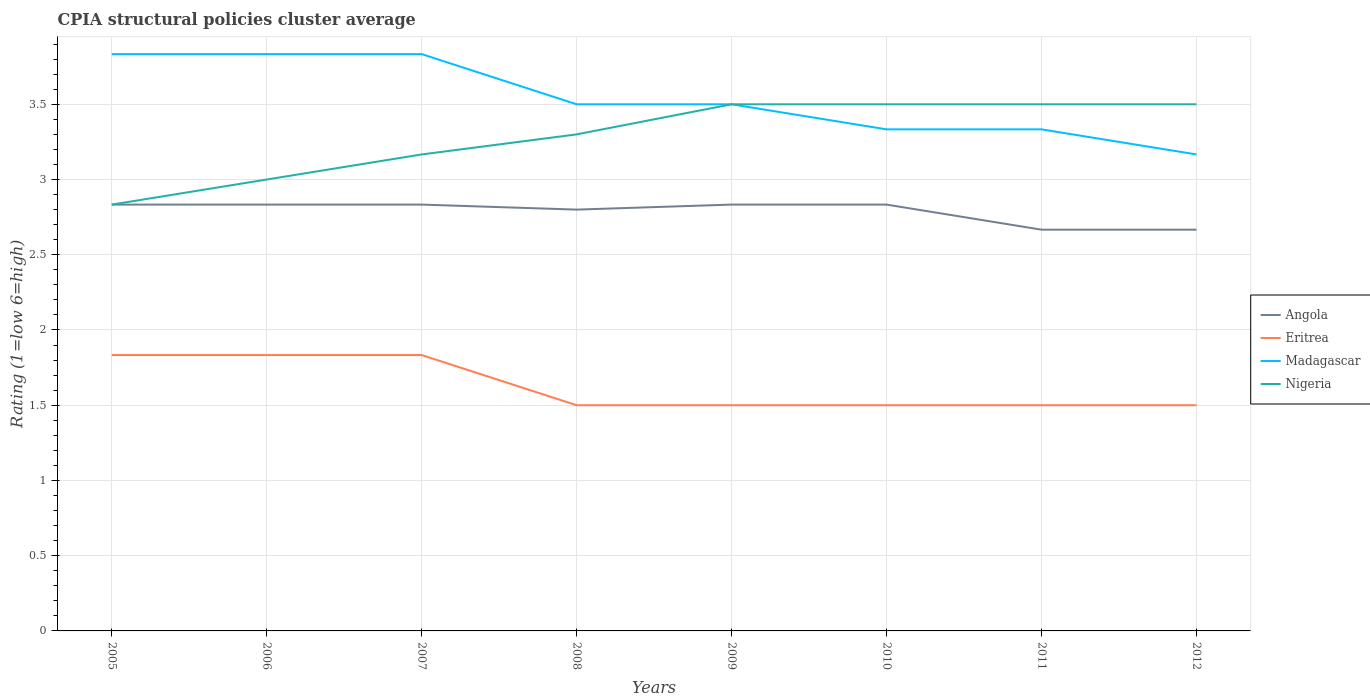How many different coloured lines are there?
Offer a very short reply. 4. Does the line corresponding to Angola intersect with the line corresponding to Madagascar?
Ensure brevity in your answer.  No. What is the total CPIA rating in Madagascar in the graph?
Keep it short and to the point. 0.17. What is the difference between the highest and the second highest CPIA rating in Nigeria?
Your answer should be very brief. 0.67. What is the difference between the highest and the lowest CPIA rating in Nigeria?
Give a very brief answer. 5. How many lines are there?
Offer a very short reply. 4. What is the difference between two consecutive major ticks on the Y-axis?
Make the answer very short. 0.5. Are the values on the major ticks of Y-axis written in scientific E-notation?
Provide a short and direct response. No. Does the graph contain grids?
Your response must be concise. Yes. Where does the legend appear in the graph?
Provide a short and direct response. Center right. How many legend labels are there?
Offer a very short reply. 4. What is the title of the graph?
Give a very brief answer. CPIA structural policies cluster average. What is the label or title of the X-axis?
Your answer should be very brief. Years. What is the Rating (1=low 6=high) in Angola in 2005?
Offer a very short reply. 2.83. What is the Rating (1=low 6=high) in Eritrea in 2005?
Keep it short and to the point. 1.83. What is the Rating (1=low 6=high) in Madagascar in 2005?
Offer a terse response. 3.83. What is the Rating (1=low 6=high) in Nigeria in 2005?
Your answer should be compact. 2.83. What is the Rating (1=low 6=high) of Angola in 2006?
Provide a short and direct response. 2.83. What is the Rating (1=low 6=high) in Eritrea in 2006?
Provide a succinct answer. 1.83. What is the Rating (1=low 6=high) in Madagascar in 2006?
Keep it short and to the point. 3.83. What is the Rating (1=low 6=high) in Angola in 2007?
Make the answer very short. 2.83. What is the Rating (1=low 6=high) of Eritrea in 2007?
Your response must be concise. 1.83. What is the Rating (1=low 6=high) in Madagascar in 2007?
Your answer should be compact. 3.83. What is the Rating (1=low 6=high) of Nigeria in 2007?
Provide a succinct answer. 3.17. What is the Rating (1=low 6=high) in Nigeria in 2008?
Give a very brief answer. 3.3. What is the Rating (1=low 6=high) of Angola in 2009?
Give a very brief answer. 2.83. What is the Rating (1=low 6=high) in Eritrea in 2009?
Keep it short and to the point. 1.5. What is the Rating (1=low 6=high) of Madagascar in 2009?
Provide a succinct answer. 3.5. What is the Rating (1=low 6=high) of Nigeria in 2009?
Provide a succinct answer. 3.5. What is the Rating (1=low 6=high) of Angola in 2010?
Your answer should be compact. 2.83. What is the Rating (1=low 6=high) of Madagascar in 2010?
Provide a succinct answer. 3.33. What is the Rating (1=low 6=high) of Nigeria in 2010?
Your answer should be compact. 3.5. What is the Rating (1=low 6=high) of Angola in 2011?
Give a very brief answer. 2.67. What is the Rating (1=low 6=high) of Madagascar in 2011?
Give a very brief answer. 3.33. What is the Rating (1=low 6=high) in Nigeria in 2011?
Your response must be concise. 3.5. What is the Rating (1=low 6=high) in Angola in 2012?
Your answer should be compact. 2.67. What is the Rating (1=low 6=high) of Madagascar in 2012?
Make the answer very short. 3.17. Across all years, what is the maximum Rating (1=low 6=high) of Angola?
Provide a short and direct response. 2.83. Across all years, what is the maximum Rating (1=low 6=high) in Eritrea?
Offer a very short reply. 1.83. Across all years, what is the maximum Rating (1=low 6=high) of Madagascar?
Offer a terse response. 3.83. Across all years, what is the maximum Rating (1=low 6=high) of Nigeria?
Offer a very short reply. 3.5. Across all years, what is the minimum Rating (1=low 6=high) in Angola?
Keep it short and to the point. 2.67. Across all years, what is the minimum Rating (1=low 6=high) in Eritrea?
Offer a terse response. 1.5. Across all years, what is the minimum Rating (1=low 6=high) of Madagascar?
Make the answer very short. 3.17. Across all years, what is the minimum Rating (1=low 6=high) of Nigeria?
Offer a very short reply. 2.83. What is the total Rating (1=low 6=high) of Angola in the graph?
Your answer should be compact. 22.3. What is the total Rating (1=low 6=high) of Eritrea in the graph?
Provide a succinct answer. 13. What is the total Rating (1=low 6=high) in Madagascar in the graph?
Offer a very short reply. 28.33. What is the total Rating (1=low 6=high) of Nigeria in the graph?
Provide a succinct answer. 26.3. What is the difference between the Rating (1=low 6=high) in Eritrea in 2005 and that in 2006?
Offer a terse response. 0. What is the difference between the Rating (1=low 6=high) in Madagascar in 2005 and that in 2006?
Offer a very short reply. 0. What is the difference between the Rating (1=low 6=high) of Nigeria in 2005 and that in 2006?
Your answer should be compact. -0.17. What is the difference between the Rating (1=low 6=high) in Angola in 2005 and that in 2007?
Keep it short and to the point. 0. What is the difference between the Rating (1=low 6=high) of Eritrea in 2005 and that in 2007?
Offer a very short reply. 0. What is the difference between the Rating (1=low 6=high) of Eritrea in 2005 and that in 2008?
Provide a short and direct response. 0.33. What is the difference between the Rating (1=low 6=high) of Madagascar in 2005 and that in 2008?
Make the answer very short. 0.33. What is the difference between the Rating (1=low 6=high) of Nigeria in 2005 and that in 2008?
Provide a succinct answer. -0.47. What is the difference between the Rating (1=low 6=high) in Angola in 2005 and that in 2009?
Make the answer very short. 0. What is the difference between the Rating (1=low 6=high) of Eritrea in 2005 and that in 2009?
Offer a terse response. 0.33. What is the difference between the Rating (1=low 6=high) of Eritrea in 2005 and that in 2010?
Offer a terse response. 0.33. What is the difference between the Rating (1=low 6=high) of Madagascar in 2005 and that in 2010?
Keep it short and to the point. 0.5. What is the difference between the Rating (1=low 6=high) in Nigeria in 2005 and that in 2011?
Your answer should be very brief. -0.67. What is the difference between the Rating (1=low 6=high) of Angola in 2005 and that in 2012?
Give a very brief answer. 0.17. What is the difference between the Rating (1=low 6=high) of Eritrea in 2005 and that in 2012?
Keep it short and to the point. 0.33. What is the difference between the Rating (1=low 6=high) in Madagascar in 2005 and that in 2012?
Your answer should be compact. 0.67. What is the difference between the Rating (1=low 6=high) in Nigeria in 2005 and that in 2012?
Your answer should be very brief. -0.67. What is the difference between the Rating (1=low 6=high) in Angola in 2006 and that in 2007?
Keep it short and to the point. 0. What is the difference between the Rating (1=low 6=high) of Eritrea in 2006 and that in 2007?
Keep it short and to the point. 0. What is the difference between the Rating (1=low 6=high) in Madagascar in 2006 and that in 2007?
Ensure brevity in your answer.  0. What is the difference between the Rating (1=low 6=high) of Angola in 2006 and that in 2009?
Provide a short and direct response. 0. What is the difference between the Rating (1=low 6=high) in Nigeria in 2006 and that in 2009?
Make the answer very short. -0.5. What is the difference between the Rating (1=low 6=high) in Eritrea in 2006 and that in 2010?
Provide a succinct answer. 0.33. What is the difference between the Rating (1=low 6=high) in Angola in 2006 and that in 2011?
Provide a succinct answer. 0.17. What is the difference between the Rating (1=low 6=high) in Eritrea in 2006 and that in 2011?
Offer a terse response. 0.33. What is the difference between the Rating (1=low 6=high) of Madagascar in 2006 and that in 2011?
Give a very brief answer. 0.5. What is the difference between the Rating (1=low 6=high) in Angola in 2006 and that in 2012?
Make the answer very short. 0.17. What is the difference between the Rating (1=low 6=high) of Eritrea in 2006 and that in 2012?
Keep it short and to the point. 0.33. What is the difference between the Rating (1=low 6=high) of Madagascar in 2006 and that in 2012?
Provide a succinct answer. 0.67. What is the difference between the Rating (1=low 6=high) of Nigeria in 2006 and that in 2012?
Your answer should be compact. -0.5. What is the difference between the Rating (1=low 6=high) of Madagascar in 2007 and that in 2008?
Make the answer very short. 0.33. What is the difference between the Rating (1=low 6=high) in Nigeria in 2007 and that in 2008?
Make the answer very short. -0.13. What is the difference between the Rating (1=low 6=high) of Angola in 2007 and that in 2009?
Give a very brief answer. 0. What is the difference between the Rating (1=low 6=high) in Madagascar in 2007 and that in 2009?
Provide a succinct answer. 0.33. What is the difference between the Rating (1=low 6=high) in Angola in 2007 and that in 2010?
Your response must be concise. 0. What is the difference between the Rating (1=low 6=high) in Eritrea in 2007 and that in 2010?
Provide a succinct answer. 0.33. What is the difference between the Rating (1=low 6=high) in Madagascar in 2007 and that in 2010?
Your answer should be compact. 0.5. What is the difference between the Rating (1=low 6=high) of Nigeria in 2007 and that in 2010?
Your response must be concise. -0.33. What is the difference between the Rating (1=low 6=high) in Angola in 2007 and that in 2011?
Give a very brief answer. 0.17. What is the difference between the Rating (1=low 6=high) of Eritrea in 2007 and that in 2012?
Provide a short and direct response. 0.33. What is the difference between the Rating (1=low 6=high) in Angola in 2008 and that in 2009?
Keep it short and to the point. -0.03. What is the difference between the Rating (1=low 6=high) in Eritrea in 2008 and that in 2009?
Offer a very short reply. 0. What is the difference between the Rating (1=low 6=high) in Madagascar in 2008 and that in 2009?
Your response must be concise. 0. What is the difference between the Rating (1=low 6=high) in Nigeria in 2008 and that in 2009?
Provide a short and direct response. -0.2. What is the difference between the Rating (1=low 6=high) in Angola in 2008 and that in 2010?
Make the answer very short. -0.03. What is the difference between the Rating (1=low 6=high) in Eritrea in 2008 and that in 2010?
Your response must be concise. 0. What is the difference between the Rating (1=low 6=high) of Madagascar in 2008 and that in 2010?
Offer a very short reply. 0.17. What is the difference between the Rating (1=low 6=high) of Angola in 2008 and that in 2011?
Your response must be concise. 0.13. What is the difference between the Rating (1=low 6=high) of Eritrea in 2008 and that in 2011?
Make the answer very short. 0. What is the difference between the Rating (1=low 6=high) in Angola in 2008 and that in 2012?
Your response must be concise. 0.13. What is the difference between the Rating (1=low 6=high) of Eritrea in 2008 and that in 2012?
Give a very brief answer. 0. What is the difference between the Rating (1=low 6=high) of Madagascar in 2008 and that in 2012?
Offer a terse response. 0.33. What is the difference between the Rating (1=low 6=high) of Angola in 2009 and that in 2010?
Your response must be concise. 0. What is the difference between the Rating (1=low 6=high) of Madagascar in 2009 and that in 2010?
Offer a terse response. 0.17. What is the difference between the Rating (1=low 6=high) in Nigeria in 2009 and that in 2011?
Give a very brief answer. 0. What is the difference between the Rating (1=low 6=high) of Angola in 2009 and that in 2012?
Make the answer very short. 0.17. What is the difference between the Rating (1=low 6=high) in Eritrea in 2009 and that in 2012?
Your response must be concise. 0. What is the difference between the Rating (1=low 6=high) in Madagascar in 2009 and that in 2012?
Ensure brevity in your answer.  0.33. What is the difference between the Rating (1=low 6=high) in Nigeria in 2009 and that in 2012?
Offer a terse response. 0. What is the difference between the Rating (1=low 6=high) in Angola in 2010 and that in 2011?
Offer a very short reply. 0.17. What is the difference between the Rating (1=low 6=high) in Madagascar in 2010 and that in 2011?
Provide a short and direct response. 0. What is the difference between the Rating (1=low 6=high) in Nigeria in 2010 and that in 2011?
Your response must be concise. 0. What is the difference between the Rating (1=low 6=high) of Angola in 2010 and that in 2012?
Your answer should be very brief. 0.17. What is the difference between the Rating (1=low 6=high) of Eritrea in 2010 and that in 2012?
Provide a succinct answer. 0. What is the difference between the Rating (1=low 6=high) of Angola in 2011 and that in 2012?
Keep it short and to the point. 0. What is the difference between the Rating (1=low 6=high) in Eritrea in 2011 and that in 2012?
Your response must be concise. 0. What is the difference between the Rating (1=low 6=high) in Nigeria in 2011 and that in 2012?
Ensure brevity in your answer.  0. What is the difference between the Rating (1=low 6=high) in Angola in 2005 and the Rating (1=low 6=high) in Eritrea in 2006?
Offer a terse response. 1. What is the difference between the Rating (1=low 6=high) of Angola in 2005 and the Rating (1=low 6=high) of Madagascar in 2006?
Keep it short and to the point. -1. What is the difference between the Rating (1=low 6=high) of Eritrea in 2005 and the Rating (1=low 6=high) of Nigeria in 2006?
Give a very brief answer. -1.17. What is the difference between the Rating (1=low 6=high) in Madagascar in 2005 and the Rating (1=low 6=high) in Nigeria in 2006?
Your answer should be very brief. 0.83. What is the difference between the Rating (1=low 6=high) of Angola in 2005 and the Rating (1=low 6=high) of Nigeria in 2007?
Provide a short and direct response. -0.33. What is the difference between the Rating (1=low 6=high) of Eritrea in 2005 and the Rating (1=low 6=high) of Madagascar in 2007?
Provide a succinct answer. -2. What is the difference between the Rating (1=low 6=high) of Eritrea in 2005 and the Rating (1=low 6=high) of Nigeria in 2007?
Give a very brief answer. -1.33. What is the difference between the Rating (1=low 6=high) in Madagascar in 2005 and the Rating (1=low 6=high) in Nigeria in 2007?
Ensure brevity in your answer.  0.67. What is the difference between the Rating (1=low 6=high) of Angola in 2005 and the Rating (1=low 6=high) of Eritrea in 2008?
Offer a very short reply. 1.33. What is the difference between the Rating (1=low 6=high) in Angola in 2005 and the Rating (1=low 6=high) in Madagascar in 2008?
Ensure brevity in your answer.  -0.67. What is the difference between the Rating (1=low 6=high) of Angola in 2005 and the Rating (1=low 6=high) of Nigeria in 2008?
Offer a terse response. -0.47. What is the difference between the Rating (1=low 6=high) in Eritrea in 2005 and the Rating (1=low 6=high) in Madagascar in 2008?
Offer a terse response. -1.67. What is the difference between the Rating (1=low 6=high) in Eritrea in 2005 and the Rating (1=low 6=high) in Nigeria in 2008?
Your response must be concise. -1.47. What is the difference between the Rating (1=low 6=high) of Madagascar in 2005 and the Rating (1=low 6=high) of Nigeria in 2008?
Your answer should be very brief. 0.53. What is the difference between the Rating (1=low 6=high) of Angola in 2005 and the Rating (1=low 6=high) of Eritrea in 2009?
Give a very brief answer. 1.33. What is the difference between the Rating (1=low 6=high) in Angola in 2005 and the Rating (1=low 6=high) in Madagascar in 2009?
Keep it short and to the point. -0.67. What is the difference between the Rating (1=low 6=high) of Eritrea in 2005 and the Rating (1=low 6=high) of Madagascar in 2009?
Keep it short and to the point. -1.67. What is the difference between the Rating (1=low 6=high) in Eritrea in 2005 and the Rating (1=low 6=high) in Nigeria in 2009?
Your answer should be very brief. -1.67. What is the difference between the Rating (1=low 6=high) of Angola in 2005 and the Rating (1=low 6=high) of Eritrea in 2010?
Make the answer very short. 1.33. What is the difference between the Rating (1=low 6=high) in Angola in 2005 and the Rating (1=low 6=high) in Nigeria in 2010?
Your answer should be compact. -0.67. What is the difference between the Rating (1=low 6=high) of Eritrea in 2005 and the Rating (1=low 6=high) of Nigeria in 2010?
Your response must be concise. -1.67. What is the difference between the Rating (1=low 6=high) of Angola in 2005 and the Rating (1=low 6=high) of Eritrea in 2011?
Ensure brevity in your answer.  1.33. What is the difference between the Rating (1=low 6=high) of Angola in 2005 and the Rating (1=low 6=high) of Madagascar in 2011?
Keep it short and to the point. -0.5. What is the difference between the Rating (1=low 6=high) of Eritrea in 2005 and the Rating (1=low 6=high) of Nigeria in 2011?
Provide a succinct answer. -1.67. What is the difference between the Rating (1=low 6=high) in Madagascar in 2005 and the Rating (1=low 6=high) in Nigeria in 2011?
Your answer should be very brief. 0.33. What is the difference between the Rating (1=low 6=high) of Angola in 2005 and the Rating (1=low 6=high) of Nigeria in 2012?
Your answer should be very brief. -0.67. What is the difference between the Rating (1=low 6=high) in Eritrea in 2005 and the Rating (1=low 6=high) in Madagascar in 2012?
Offer a very short reply. -1.33. What is the difference between the Rating (1=low 6=high) in Eritrea in 2005 and the Rating (1=low 6=high) in Nigeria in 2012?
Provide a succinct answer. -1.67. What is the difference between the Rating (1=low 6=high) of Angola in 2006 and the Rating (1=low 6=high) of Eritrea in 2007?
Your answer should be compact. 1. What is the difference between the Rating (1=low 6=high) in Eritrea in 2006 and the Rating (1=low 6=high) in Madagascar in 2007?
Your answer should be compact. -2. What is the difference between the Rating (1=low 6=high) of Eritrea in 2006 and the Rating (1=low 6=high) of Nigeria in 2007?
Give a very brief answer. -1.33. What is the difference between the Rating (1=low 6=high) in Madagascar in 2006 and the Rating (1=low 6=high) in Nigeria in 2007?
Make the answer very short. 0.67. What is the difference between the Rating (1=low 6=high) of Angola in 2006 and the Rating (1=low 6=high) of Eritrea in 2008?
Provide a succinct answer. 1.33. What is the difference between the Rating (1=low 6=high) of Angola in 2006 and the Rating (1=low 6=high) of Nigeria in 2008?
Give a very brief answer. -0.47. What is the difference between the Rating (1=low 6=high) in Eritrea in 2006 and the Rating (1=low 6=high) in Madagascar in 2008?
Offer a very short reply. -1.67. What is the difference between the Rating (1=low 6=high) of Eritrea in 2006 and the Rating (1=low 6=high) of Nigeria in 2008?
Your answer should be compact. -1.47. What is the difference between the Rating (1=low 6=high) of Madagascar in 2006 and the Rating (1=low 6=high) of Nigeria in 2008?
Offer a terse response. 0.53. What is the difference between the Rating (1=low 6=high) in Angola in 2006 and the Rating (1=low 6=high) in Madagascar in 2009?
Keep it short and to the point. -0.67. What is the difference between the Rating (1=low 6=high) in Eritrea in 2006 and the Rating (1=low 6=high) in Madagascar in 2009?
Offer a terse response. -1.67. What is the difference between the Rating (1=low 6=high) of Eritrea in 2006 and the Rating (1=low 6=high) of Nigeria in 2009?
Give a very brief answer. -1.67. What is the difference between the Rating (1=low 6=high) in Madagascar in 2006 and the Rating (1=low 6=high) in Nigeria in 2009?
Offer a terse response. 0.33. What is the difference between the Rating (1=low 6=high) of Angola in 2006 and the Rating (1=low 6=high) of Madagascar in 2010?
Provide a succinct answer. -0.5. What is the difference between the Rating (1=low 6=high) of Eritrea in 2006 and the Rating (1=low 6=high) of Madagascar in 2010?
Provide a succinct answer. -1.5. What is the difference between the Rating (1=low 6=high) in Eritrea in 2006 and the Rating (1=low 6=high) in Nigeria in 2010?
Your answer should be compact. -1.67. What is the difference between the Rating (1=low 6=high) of Madagascar in 2006 and the Rating (1=low 6=high) of Nigeria in 2010?
Make the answer very short. 0.33. What is the difference between the Rating (1=low 6=high) of Angola in 2006 and the Rating (1=low 6=high) of Eritrea in 2011?
Provide a short and direct response. 1.33. What is the difference between the Rating (1=low 6=high) in Eritrea in 2006 and the Rating (1=low 6=high) in Nigeria in 2011?
Provide a short and direct response. -1.67. What is the difference between the Rating (1=low 6=high) in Angola in 2006 and the Rating (1=low 6=high) in Eritrea in 2012?
Make the answer very short. 1.33. What is the difference between the Rating (1=low 6=high) in Eritrea in 2006 and the Rating (1=low 6=high) in Madagascar in 2012?
Your response must be concise. -1.33. What is the difference between the Rating (1=low 6=high) in Eritrea in 2006 and the Rating (1=low 6=high) in Nigeria in 2012?
Make the answer very short. -1.67. What is the difference between the Rating (1=low 6=high) in Angola in 2007 and the Rating (1=low 6=high) in Eritrea in 2008?
Give a very brief answer. 1.33. What is the difference between the Rating (1=low 6=high) of Angola in 2007 and the Rating (1=low 6=high) of Madagascar in 2008?
Give a very brief answer. -0.67. What is the difference between the Rating (1=low 6=high) in Angola in 2007 and the Rating (1=low 6=high) in Nigeria in 2008?
Provide a succinct answer. -0.47. What is the difference between the Rating (1=low 6=high) of Eritrea in 2007 and the Rating (1=low 6=high) of Madagascar in 2008?
Your answer should be very brief. -1.67. What is the difference between the Rating (1=low 6=high) of Eritrea in 2007 and the Rating (1=low 6=high) of Nigeria in 2008?
Keep it short and to the point. -1.47. What is the difference between the Rating (1=low 6=high) of Madagascar in 2007 and the Rating (1=low 6=high) of Nigeria in 2008?
Your answer should be very brief. 0.53. What is the difference between the Rating (1=low 6=high) in Angola in 2007 and the Rating (1=low 6=high) in Eritrea in 2009?
Your answer should be very brief. 1.33. What is the difference between the Rating (1=low 6=high) of Angola in 2007 and the Rating (1=low 6=high) of Madagascar in 2009?
Keep it short and to the point. -0.67. What is the difference between the Rating (1=low 6=high) of Angola in 2007 and the Rating (1=low 6=high) of Nigeria in 2009?
Your answer should be very brief. -0.67. What is the difference between the Rating (1=low 6=high) of Eritrea in 2007 and the Rating (1=low 6=high) of Madagascar in 2009?
Provide a succinct answer. -1.67. What is the difference between the Rating (1=low 6=high) of Eritrea in 2007 and the Rating (1=low 6=high) of Nigeria in 2009?
Your answer should be compact. -1.67. What is the difference between the Rating (1=low 6=high) of Angola in 2007 and the Rating (1=low 6=high) of Eritrea in 2010?
Keep it short and to the point. 1.33. What is the difference between the Rating (1=low 6=high) of Angola in 2007 and the Rating (1=low 6=high) of Nigeria in 2010?
Make the answer very short. -0.67. What is the difference between the Rating (1=low 6=high) in Eritrea in 2007 and the Rating (1=low 6=high) in Nigeria in 2010?
Your answer should be very brief. -1.67. What is the difference between the Rating (1=low 6=high) in Angola in 2007 and the Rating (1=low 6=high) in Madagascar in 2011?
Ensure brevity in your answer.  -0.5. What is the difference between the Rating (1=low 6=high) in Eritrea in 2007 and the Rating (1=low 6=high) in Madagascar in 2011?
Provide a succinct answer. -1.5. What is the difference between the Rating (1=low 6=high) of Eritrea in 2007 and the Rating (1=low 6=high) of Nigeria in 2011?
Your answer should be compact. -1.67. What is the difference between the Rating (1=low 6=high) of Angola in 2007 and the Rating (1=low 6=high) of Eritrea in 2012?
Give a very brief answer. 1.33. What is the difference between the Rating (1=low 6=high) of Angola in 2007 and the Rating (1=low 6=high) of Nigeria in 2012?
Offer a terse response. -0.67. What is the difference between the Rating (1=low 6=high) in Eritrea in 2007 and the Rating (1=low 6=high) in Madagascar in 2012?
Your answer should be very brief. -1.33. What is the difference between the Rating (1=low 6=high) of Eritrea in 2007 and the Rating (1=low 6=high) of Nigeria in 2012?
Keep it short and to the point. -1.67. What is the difference between the Rating (1=low 6=high) in Madagascar in 2007 and the Rating (1=low 6=high) in Nigeria in 2012?
Ensure brevity in your answer.  0.33. What is the difference between the Rating (1=low 6=high) of Angola in 2008 and the Rating (1=low 6=high) of Madagascar in 2009?
Ensure brevity in your answer.  -0.7. What is the difference between the Rating (1=low 6=high) in Eritrea in 2008 and the Rating (1=low 6=high) in Madagascar in 2009?
Your response must be concise. -2. What is the difference between the Rating (1=low 6=high) of Eritrea in 2008 and the Rating (1=low 6=high) of Nigeria in 2009?
Keep it short and to the point. -2. What is the difference between the Rating (1=low 6=high) in Angola in 2008 and the Rating (1=low 6=high) in Eritrea in 2010?
Ensure brevity in your answer.  1.3. What is the difference between the Rating (1=low 6=high) of Angola in 2008 and the Rating (1=low 6=high) of Madagascar in 2010?
Provide a short and direct response. -0.53. What is the difference between the Rating (1=low 6=high) of Eritrea in 2008 and the Rating (1=low 6=high) of Madagascar in 2010?
Provide a succinct answer. -1.83. What is the difference between the Rating (1=low 6=high) of Madagascar in 2008 and the Rating (1=low 6=high) of Nigeria in 2010?
Keep it short and to the point. 0. What is the difference between the Rating (1=low 6=high) of Angola in 2008 and the Rating (1=low 6=high) of Madagascar in 2011?
Ensure brevity in your answer.  -0.53. What is the difference between the Rating (1=low 6=high) in Eritrea in 2008 and the Rating (1=low 6=high) in Madagascar in 2011?
Offer a very short reply. -1.83. What is the difference between the Rating (1=low 6=high) in Eritrea in 2008 and the Rating (1=low 6=high) in Nigeria in 2011?
Offer a terse response. -2. What is the difference between the Rating (1=low 6=high) in Madagascar in 2008 and the Rating (1=low 6=high) in Nigeria in 2011?
Keep it short and to the point. 0. What is the difference between the Rating (1=low 6=high) of Angola in 2008 and the Rating (1=low 6=high) of Eritrea in 2012?
Provide a succinct answer. 1.3. What is the difference between the Rating (1=low 6=high) of Angola in 2008 and the Rating (1=low 6=high) of Madagascar in 2012?
Give a very brief answer. -0.37. What is the difference between the Rating (1=low 6=high) in Angola in 2008 and the Rating (1=low 6=high) in Nigeria in 2012?
Offer a very short reply. -0.7. What is the difference between the Rating (1=low 6=high) of Eritrea in 2008 and the Rating (1=low 6=high) of Madagascar in 2012?
Ensure brevity in your answer.  -1.67. What is the difference between the Rating (1=low 6=high) of Eritrea in 2009 and the Rating (1=low 6=high) of Madagascar in 2010?
Make the answer very short. -1.83. What is the difference between the Rating (1=low 6=high) in Eritrea in 2009 and the Rating (1=low 6=high) in Nigeria in 2010?
Give a very brief answer. -2. What is the difference between the Rating (1=low 6=high) in Madagascar in 2009 and the Rating (1=low 6=high) in Nigeria in 2010?
Offer a very short reply. 0. What is the difference between the Rating (1=low 6=high) in Angola in 2009 and the Rating (1=low 6=high) in Eritrea in 2011?
Make the answer very short. 1.33. What is the difference between the Rating (1=low 6=high) in Angola in 2009 and the Rating (1=low 6=high) in Nigeria in 2011?
Ensure brevity in your answer.  -0.67. What is the difference between the Rating (1=low 6=high) in Eritrea in 2009 and the Rating (1=low 6=high) in Madagascar in 2011?
Your response must be concise. -1.83. What is the difference between the Rating (1=low 6=high) of Eritrea in 2009 and the Rating (1=low 6=high) of Madagascar in 2012?
Keep it short and to the point. -1.67. What is the difference between the Rating (1=low 6=high) in Madagascar in 2009 and the Rating (1=low 6=high) in Nigeria in 2012?
Ensure brevity in your answer.  0. What is the difference between the Rating (1=low 6=high) of Angola in 2010 and the Rating (1=low 6=high) of Eritrea in 2011?
Your answer should be very brief. 1.33. What is the difference between the Rating (1=low 6=high) in Angola in 2010 and the Rating (1=low 6=high) in Madagascar in 2011?
Make the answer very short. -0.5. What is the difference between the Rating (1=low 6=high) of Angola in 2010 and the Rating (1=low 6=high) of Nigeria in 2011?
Keep it short and to the point. -0.67. What is the difference between the Rating (1=low 6=high) in Eritrea in 2010 and the Rating (1=low 6=high) in Madagascar in 2011?
Offer a terse response. -1.83. What is the difference between the Rating (1=low 6=high) in Angola in 2010 and the Rating (1=low 6=high) in Eritrea in 2012?
Keep it short and to the point. 1.33. What is the difference between the Rating (1=low 6=high) of Eritrea in 2010 and the Rating (1=low 6=high) of Madagascar in 2012?
Provide a succinct answer. -1.67. What is the difference between the Rating (1=low 6=high) in Eritrea in 2010 and the Rating (1=low 6=high) in Nigeria in 2012?
Your answer should be compact. -2. What is the difference between the Rating (1=low 6=high) of Eritrea in 2011 and the Rating (1=low 6=high) of Madagascar in 2012?
Offer a terse response. -1.67. What is the difference between the Rating (1=low 6=high) of Madagascar in 2011 and the Rating (1=low 6=high) of Nigeria in 2012?
Make the answer very short. -0.17. What is the average Rating (1=low 6=high) of Angola per year?
Give a very brief answer. 2.79. What is the average Rating (1=low 6=high) of Eritrea per year?
Offer a very short reply. 1.62. What is the average Rating (1=low 6=high) in Madagascar per year?
Your answer should be compact. 3.54. What is the average Rating (1=low 6=high) of Nigeria per year?
Offer a terse response. 3.29. In the year 2005, what is the difference between the Rating (1=low 6=high) in Eritrea and Rating (1=low 6=high) in Nigeria?
Make the answer very short. -1. In the year 2005, what is the difference between the Rating (1=low 6=high) in Madagascar and Rating (1=low 6=high) in Nigeria?
Make the answer very short. 1. In the year 2006, what is the difference between the Rating (1=low 6=high) of Angola and Rating (1=low 6=high) of Eritrea?
Your answer should be compact. 1. In the year 2006, what is the difference between the Rating (1=low 6=high) of Angola and Rating (1=low 6=high) of Madagascar?
Give a very brief answer. -1. In the year 2006, what is the difference between the Rating (1=low 6=high) of Eritrea and Rating (1=low 6=high) of Madagascar?
Your answer should be compact. -2. In the year 2006, what is the difference between the Rating (1=low 6=high) in Eritrea and Rating (1=low 6=high) in Nigeria?
Offer a terse response. -1.17. In the year 2007, what is the difference between the Rating (1=low 6=high) in Angola and Rating (1=low 6=high) in Eritrea?
Provide a succinct answer. 1. In the year 2007, what is the difference between the Rating (1=low 6=high) in Angola and Rating (1=low 6=high) in Nigeria?
Offer a very short reply. -0.33. In the year 2007, what is the difference between the Rating (1=low 6=high) in Eritrea and Rating (1=low 6=high) in Nigeria?
Offer a very short reply. -1.33. In the year 2008, what is the difference between the Rating (1=low 6=high) in Angola and Rating (1=low 6=high) in Nigeria?
Your answer should be very brief. -0.5. In the year 2008, what is the difference between the Rating (1=low 6=high) in Madagascar and Rating (1=low 6=high) in Nigeria?
Your answer should be very brief. 0.2. In the year 2009, what is the difference between the Rating (1=low 6=high) of Angola and Rating (1=low 6=high) of Madagascar?
Your answer should be compact. -0.67. In the year 2009, what is the difference between the Rating (1=low 6=high) in Eritrea and Rating (1=low 6=high) in Nigeria?
Provide a succinct answer. -2. In the year 2009, what is the difference between the Rating (1=low 6=high) in Madagascar and Rating (1=low 6=high) in Nigeria?
Ensure brevity in your answer.  0. In the year 2010, what is the difference between the Rating (1=low 6=high) of Angola and Rating (1=low 6=high) of Madagascar?
Make the answer very short. -0.5. In the year 2010, what is the difference between the Rating (1=low 6=high) of Eritrea and Rating (1=low 6=high) of Madagascar?
Your answer should be compact. -1.83. In the year 2010, what is the difference between the Rating (1=low 6=high) of Eritrea and Rating (1=low 6=high) of Nigeria?
Offer a terse response. -2. In the year 2010, what is the difference between the Rating (1=low 6=high) of Madagascar and Rating (1=low 6=high) of Nigeria?
Provide a succinct answer. -0.17. In the year 2011, what is the difference between the Rating (1=low 6=high) in Angola and Rating (1=low 6=high) in Eritrea?
Offer a terse response. 1.17. In the year 2011, what is the difference between the Rating (1=low 6=high) in Angola and Rating (1=low 6=high) in Madagascar?
Offer a terse response. -0.67. In the year 2011, what is the difference between the Rating (1=low 6=high) in Angola and Rating (1=low 6=high) in Nigeria?
Provide a succinct answer. -0.83. In the year 2011, what is the difference between the Rating (1=low 6=high) of Eritrea and Rating (1=low 6=high) of Madagascar?
Offer a very short reply. -1.83. In the year 2012, what is the difference between the Rating (1=low 6=high) of Angola and Rating (1=low 6=high) of Nigeria?
Offer a terse response. -0.83. In the year 2012, what is the difference between the Rating (1=low 6=high) in Eritrea and Rating (1=low 6=high) in Madagascar?
Ensure brevity in your answer.  -1.67. In the year 2012, what is the difference between the Rating (1=low 6=high) of Eritrea and Rating (1=low 6=high) of Nigeria?
Keep it short and to the point. -2. In the year 2012, what is the difference between the Rating (1=low 6=high) of Madagascar and Rating (1=low 6=high) of Nigeria?
Ensure brevity in your answer.  -0.33. What is the ratio of the Rating (1=low 6=high) in Eritrea in 2005 to that in 2006?
Your answer should be very brief. 1. What is the ratio of the Rating (1=low 6=high) in Madagascar in 2005 to that in 2006?
Your answer should be compact. 1. What is the ratio of the Rating (1=low 6=high) of Nigeria in 2005 to that in 2006?
Give a very brief answer. 0.94. What is the ratio of the Rating (1=low 6=high) of Madagascar in 2005 to that in 2007?
Give a very brief answer. 1. What is the ratio of the Rating (1=low 6=high) of Nigeria in 2005 to that in 2007?
Make the answer very short. 0.89. What is the ratio of the Rating (1=low 6=high) of Angola in 2005 to that in 2008?
Provide a succinct answer. 1.01. What is the ratio of the Rating (1=low 6=high) of Eritrea in 2005 to that in 2008?
Your response must be concise. 1.22. What is the ratio of the Rating (1=low 6=high) of Madagascar in 2005 to that in 2008?
Offer a terse response. 1.1. What is the ratio of the Rating (1=low 6=high) in Nigeria in 2005 to that in 2008?
Provide a succinct answer. 0.86. What is the ratio of the Rating (1=low 6=high) in Eritrea in 2005 to that in 2009?
Your answer should be compact. 1.22. What is the ratio of the Rating (1=low 6=high) in Madagascar in 2005 to that in 2009?
Your response must be concise. 1.1. What is the ratio of the Rating (1=low 6=high) of Nigeria in 2005 to that in 2009?
Make the answer very short. 0.81. What is the ratio of the Rating (1=low 6=high) of Angola in 2005 to that in 2010?
Make the answer very short. 1. What is the ratio of the Rating (1=low 6=high) of Eritrea in 2005 to that in 2010?
Provide a short and direct response. 1.22. What is the ratio of the Rating (1=low 6=high) in Madagascar in 2005 to that in 2010?
Ensure brevity in your answer.  1.15. What is the ratio of the Rating (1=low 6=high) of Nigeria in 2005 to that in 2010?
Your response must be concise. 0.81. What is the ratio of the Rating (1=low 6=high) in Eritrea in 2005 to that in 2011?
Keep it short and to the point. 1.22. What is the ratio of the Rating (1=low 6=high) of Madagascar in 2005 to that in 2011?
Offer a very short reply. 1.15. What is the ratio of the Rating (1=low 6=high) in Nigeria in 2005 to that in 2011?
Your response must be concise. 0.81. What is the ratio of the Rating (1=low 6=high) of Angola in 2005 to that in 2012?
Your response must be concise. 1.06. What is the ratio of the Rating (1=low 6=high) of Eritrea in 2005 to that in 2012?
Give a very brief answer. 1.22. What is the ratio of the Rating (1=low 6=high) of Madagascar in 2005 to that in 2012?
Offer a very short reply. 1.21. What is the ratio of the Rating (1=low 6=high) in Nigeria in 2005 to that in 2012?
Make the answer very short. 0.81. What is the ratio of the Rating (1=low 6=high) in Angola in 2006 to that in 2007?
Offer a terse response. 1. What is the ratio of the Rating (1=low 6=high) of Eritrea in 2006 to that in 2007?
Keep it short and to the point. 1. What is the ratio of the Rating (1=low 6=high) of Nigeria in 2006 to that in 2007?
Your response must be concise. 0.95. What is the ratio of the Rating (1=low 6=high) in Angola in 2006 to that in 2008?
Ensure brevity in your answer.  1.01. What is the ratio of the Rating (1=low 6=high) of Eritrea in 2006 to that in 2008?
Your answer should be very brief. 1.22. What is the ratio of the Rating (1=low 6=high) in Madagascar in 2006 to that in 2008?
Offer a terse response. 1.1. What is the ratio of the Rating (1=low 6=high) in Nigeria in 2006 to that in 2008?
Your answer should be compact. 0.91. What is the ratio of the Rating (1=low 6=high) in Eritrea in 2006 to that in 2009?
Give a very brief answer. 1.22. What is the ratio of the Rating (1=low 6=high) in Madagascar in 2006 to that in 2009?
Provide a short and direct response. 1.1. What is the ratio of the Rating (1=low 6=high) in Nigeria in 2006 to that in 2009?
Your answer should be very brief. 0.86. What is the ratio of the Rating (1=low 6=high) in Angola in 2006 to that in 2010?
Offer a very short reply. 1. What is the ratio of the Rating (1=low 6=high) in Eritrea in 2006 to that in 2010?
Your response must be concise. 1.22. What is the ratio of the Rating (1=low 6=high) of Madagascar in 2006 to that in 2010?
Ensure brevity in your answer.  1.15. What is the ratio of the Rating (1=low 6=high) in Eritrea in 2006 to that in 2011?
Your answer should be very brief. 1.22. What is the ratio of the Rating (1=low 6=high) in Madagascar in 2006 to that in 2011?
Offer a very short reply. 1.15. What is the ratio of the Rating (1=low 6=high) in Angola in 2006 to that in 2012?
Keep it short and to the point. 1.06. What is the ratio of the Rating (1=low 6=high) of Eritrea in 2006 to that in 2012?
Provide a succinct answer. 1.22. What is the ratio of the Rating (1=low 6=high) of Madagascar in 2006 to that in 2012?
Your response must be concise. 1.21. What is the ratio of the Rating (1=low 6=high) of Angola in 2007 to that in 2008?
Your answer should be very brief. 1.01. What is the ratio of the Rating (1=low 6=high) of Eritrea in 2007 to that in 2008?
Provide a short and direct response. 1.22. What is the ratio of the Rating (1=low 6=high) of Madagascar in 2007 to that in 2008?
Keep it short and to the point. 1.1. What is the ratio of the Rating (1=low 6=high) of Nigeria in 2007 to that in 2008?
Give a very brief answer. 0.96. What is the ratio of the Rating (1=low 6=high) in Eritrea in 2007 to that in 2009?
Offer a terse response. 1.22. What is the ratio of the Rating (1=low 6=high) in Madagascar in 2007 to that in 2009?
Ensure brevity in your answer.  1.1. What is the ratio of the Rating (1=low 6=high) in Nigeria in 2007 to that in 2009?
Ensure brevity in your answer.  0.9. What is the ratio of the Rating (1=low 6=high) of Angola in 2007 to that in 2010?
Provide a succinct answer. 1. What is the ratio of the Rating (1=low 6=high) in Eritrea in 2007 to that in 2010?
Make the answer very short. 1.22. What is the ratio of the Rating (1=low 6=high) of Madagascar in 2007 to that in 2010?
Offer a very short reply. 1.15. What is the ratio of the Rating (1=low 6=high) in Nigeria in 2007 to that in 2010?
Your response must be concise. 0.9. What is the ratio of the Rating (1=low 6=high) in Eritrea in 2007 to that in 2011?
Offer a very short reply. 1.22. What is the ratio of the Rating (1=low 6=high) of Madagascar in 2007 to that in 2011?
Your response must be concise. 1.15. What is the ratio of the Rating (1=low 6=high) in Nigeria in 2007 to that in 2011?
Provide a short and direct response. 0.9. What is the ratio of the Rating (1=low 6=high) of Angola in 2007 to that in 2012?
Give a very brief answer. 1.06. What is the ratio of the Rating (1=low 6=high) of Eritrea in 2007 to that in 2012?
Keep it short and to the point. 1.22. What is the ratio of the Rating (1=low 6=high) in Madagascar in 2007 to that in 2012?
Provide a succinct answer. 1.21. What is the ratio of the Rating (1=low 6=high) in Nigeria in 2007 to that in 2012?
Offer a terse response. 0.9. What is the ratio of the Rating (1=low 6=high) of Angola in 2008 to that in 2009?
Offer a very short reply. 0.99. What is the ratio of the Rating (1=low 6=high) in Eritrea in 2008 to that in 2009?
Make the answer very short. 1. What is the ratio of the Rating (1=low 6=high) of Nigeria in 2008 to that in 2009?
Provide a short and direct response. 0.94. What is the ratio of the Rating (1=low 6=high) of Nigeria in 2008 to that in 2010?
Provide a succinct answer. 0.94. What is the ratio of the Rating (1=low 6=high) of Angola in 2008 to that in 2011?
Offer a very short reply. 1.05. What is the ratio of the Rating (1=low 6=high) of Eritrea in 2008 to that in 2011?
Your response must be concise. 1. What is the ratio of the Rating (1=low 6=high) in Nigeria in 2008 to that in 2011?
Give a very brief answer. 0.94. What is the ratio of the Rating (1=low 6=high) of Angola in 2008 to that in 2012?
Offer a very short reply. 1.05. What is the ratio of the Rating (1=low 6=high) of Madagascar in 2008 to that in 2012?
Keep it short and to the point. 1.11. What is the ratio of the Rating (1=low 6=high) in Nigeria in 2008 to that in 2012?
Provide a succinct answer. 0.94. What is the ratio of the Rating (1=low 6=high) of Eritrea in 2009 to that in 2010?
Make the answer very short. 1. What is the ratio of the Rating (1=low 6=high) in Nigeria in 2009 to that in 2010?
Keep it short and to the point. 1. What is the ratio of the Rating (1=low 6=high) in Nigeria in 2009 to that in 2011?
Make the answer very short. 1. What is the ratio of the Rating (1=low 6=high) in Angola in 2009 to that in 2012?
Your answer should be very brief. 1.06. What is the ratio of the Rating (1=low 6=high) of Eritrea in 2009 to that in 2012?
Give a very brief answer. 1. What is the ratio of the Rating (1=low 6=high) in Madagascar in 2009 to that in 2012?
Provide a succinct answer. 1.11. What is the ratio of the Rating (1=low 6=high) in Nigeria in 2009 to that in 2012?
Your response must be concise. 1. What is the ratio of the Rating (1=low 6=high) of Eritrea in 2010 to that in 2011?
Keep it short and to the point. 1. What is the ratio of the Rating (1=low 6=high) in Madagascar in 2010 to that in 2011?
Provide a short and direct response. 1. What is the ratio of the Rating (1=low 6=high) in Nigeria in 2010 to that in 2011?
Your response must be concise. 1. What is the ratio of the Rating (1=low 6=high) of Angola in 2010 to that in 2012?
Provide a succinct answer. 1.06. What is the ratio of the Rating (1=low 6=high) in Eritrea in 2010 to that in 2012?
Keep it short and to the point. 1. What is the ratio of the Rating (1=low 6=high) in Madagascar in 2010 to that in 2012?
Provide a short and direct response. 1.05. What is the ratio of the Rating (1=low 6=high) in Nigeria in 2010 to that in 2012?
Keep it short and to the point. 1. What is the ratio of the Rating (1=low 6=high) in Madagascar in 2011 to that in 2012?
Give a very brief answer. 1.05. What is the ratio of the Rating (1=low 6=high) of Nigeria in 2011 to that in 2012?
Give a very brief answer. 1. What is the difference between the highest and the second highest Rating (1=low 6=high) of Angola?
Give a very brief answer. 0. What is the difference between the highest and the second highest Rating (1=low 6=high) of Nigeria?
Your answer should be compact. 0. What is the difference between the highest and the lowest Rating (1=low 6=high) in Eritrea?
Make the answer very short. 0.33. What is the difference between the highest and the lowest Rating (1=low 6=high) in Madagascar?
Ensure brevity in your answer.  0.67. 